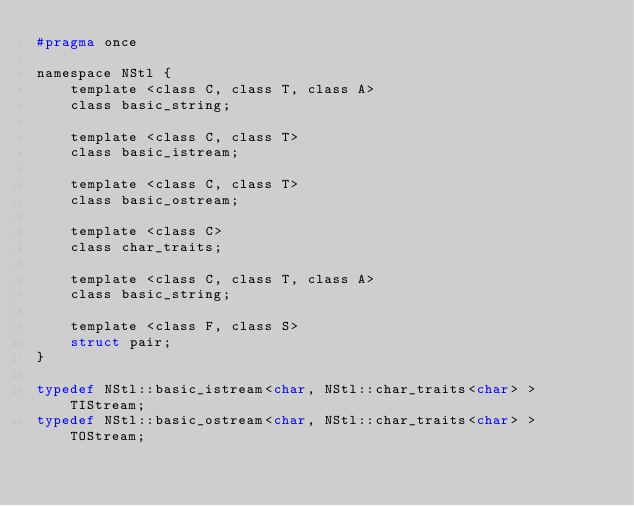Convert code to text. <code><loc_0><loc_0><loc_500><loc_500><_C_>#pragma once

namespace NStl {
    template <class C, class T, class A>
    class basic_string;

    template <class C, class T>
    class basic_istream;

    template <class C, class T>
    class basic_ostream;

    template <class C>
    class char_traits;

    template <class C, class T, class A>
    class basic_string;

    template <class F, class S>
    struct pair;
}

typedef NStl::basic_istream<char, NStl::char_traits<char> > TIStream;
typedef NStl::basic_ostream<char, NStl::char_traits<char> > TOStream;
</code> 